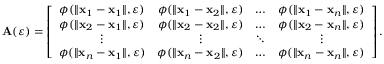<formula> <loc_0><loc_0><loc_500><loc_500>A ( \varepsilon ) = \left [ \begin{array} { c c c c } { \phi ( \| x _ { 1 } - x _ { 1 } \| , \varepsilon ) } & { \phi ( \| x _ { 1 } - x _ { 2 } \| , \varepsilon ) } & { \dots } & { \phi ( \| x _ { 1 } - x _ { n } \| , \varepsilon ) } \\ { \phi ( \| x _ { 2 } - x _ { 1 } \| , \varepsilon ) } & { \phi ( \| x _ { 2 } - x _ { 2 } \| , \varepsilon ) } & { \dots } & { \phi ( \| x _ { 2 } - x _ { n } \| , \varepsilon ) } \\ { \vdots } & { \vdots } & { \ddots } & { \vdots } \\ { \phi ( \| x _ { n } - x _ { 1 } \| , \varepsilon ) } & { \phi ( \| x _ { n } - x _ { 2 } \| , \varepsilon ) } & { \dots } & { \phi ( \| x _ { n } - x _ { n } \| , \varepsilon ) } \end{array} \right ] .</formula> 